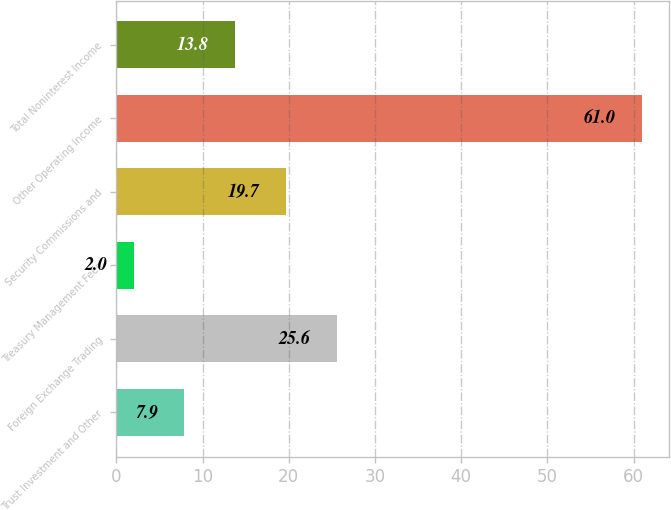<chart> <loc_0><loc_0><loc_500><loc_500><bar_chart><fcel>Trust Investment and Other<fcel>Foreign Exchange Trading<fcel>Treasury Management Fees<fcel>Security Commissions and<fcel>Other Operating Income<fcel>Total Noninterest Income<nl><fcel>7.9<fcel>25.6<fcel>2<fcel>19.7<fcel>61<fcel>13.8<nl></chart> 